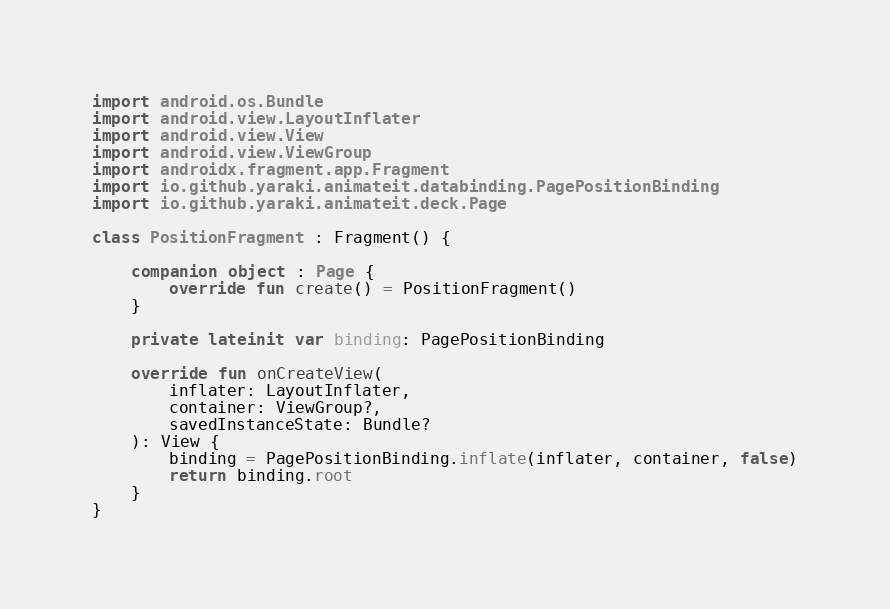Convert code to text. <code><loc_0><loc_0><loc_500><loc_500><_Kotlin_>import android.os.Bundle
import android.view.LayoutInflater
import android.view.View
import android.view.ViewGroup
import androidx.fragment.app.Fragment
import io.github.yaraki.animateit.databinding.PagePositionBinding
import io.github.yaraki.animateit.deck.Page

class PositionFragment : Fragment() {

    companion object : Page {
        override fun create() = PositionFragment()
    }

    private lateinit var binding: PagePositionBinding

    override fun onCreateView(
        inflater: LayoutInflater,
        container: ViewGroup?,
        savedInstanceState: Bundle?
    ): View {
        binding = PagePositionBinding.inflate(inflater, container, false)
        return binding.root
    }
}
</code> 